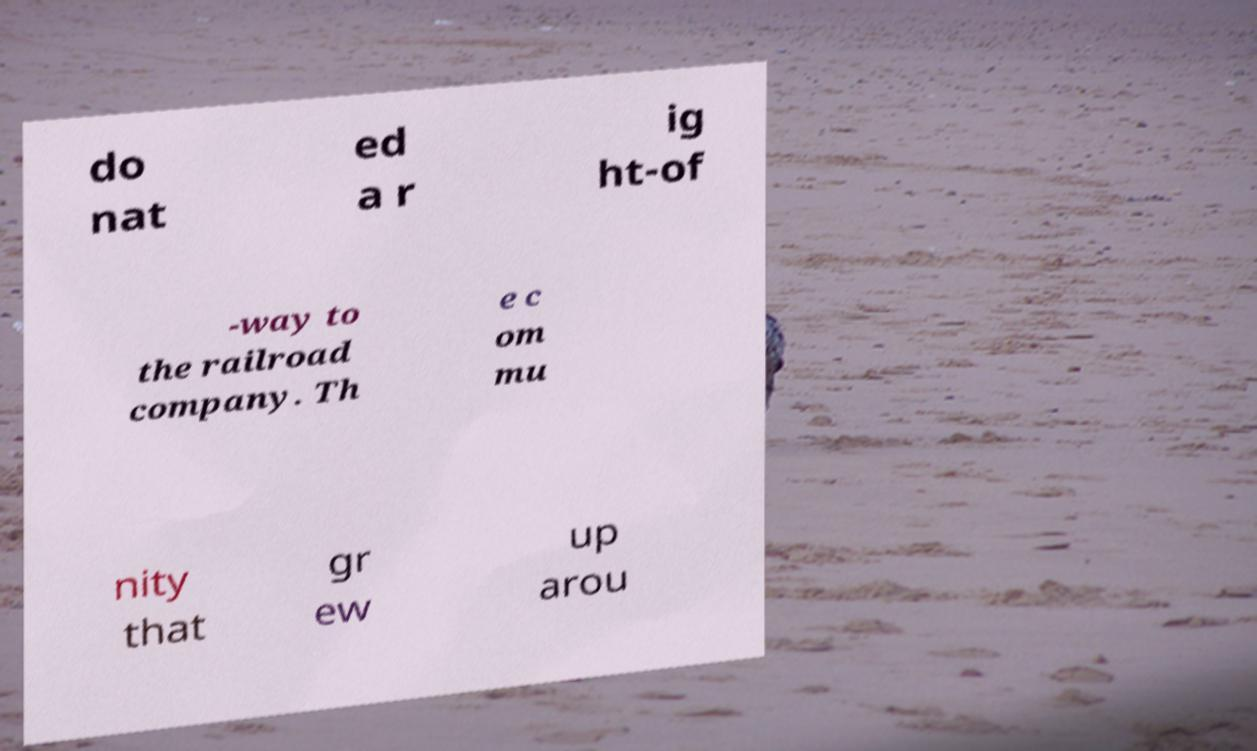What messages or text are displayed in this image? I need them in a readable, typed format. do nat ed a r ig ht-of -way to the railroad company. Th e c om mu nity that gr ew up arou 